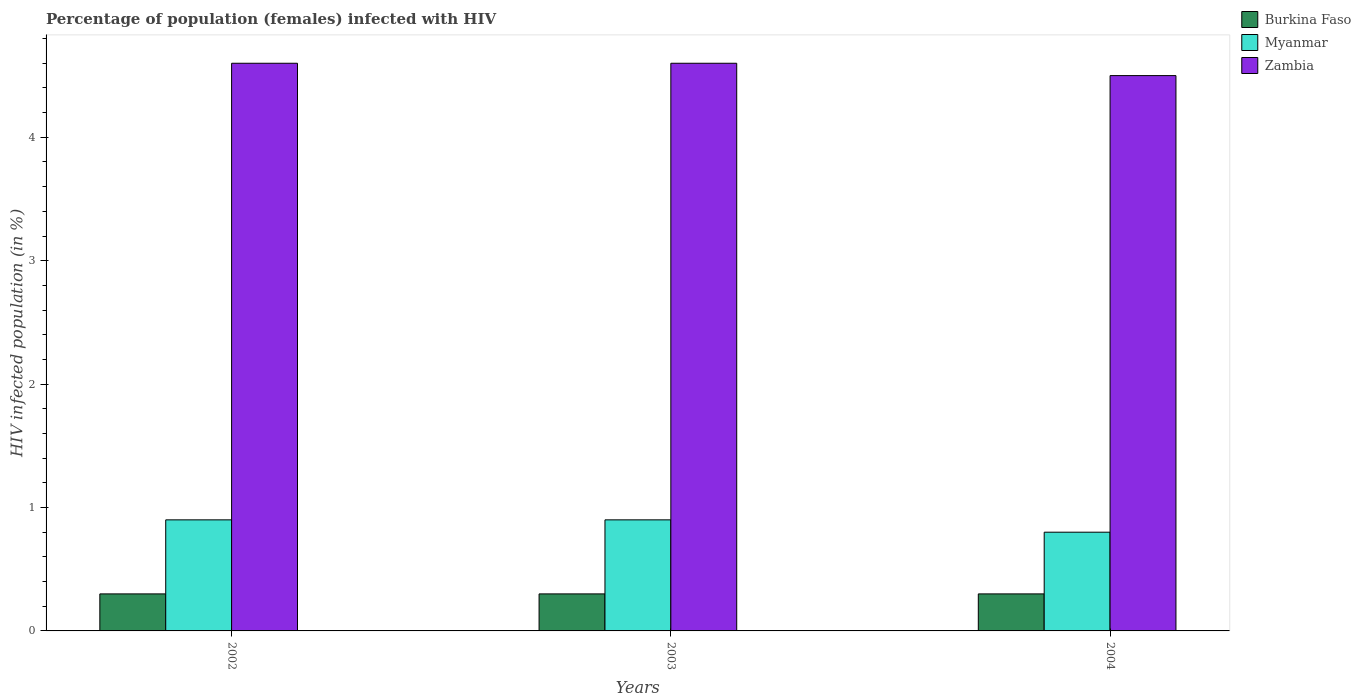How many groups of bars are there?
Offer a very short reply. 3. Are the number of bars per tick equal to the number of legend labels?
Offer a very short reply. Yes. How many bars are there on the 3rd tick from the left?
Ensure brevity in your answer.  3. What is the label of the 1st group of bars from the left?
Your response must be concise. 2002. What is the percentage of HIV infected female population in Zambia in 2003?
Your answer should be compact. 4.6. Across all years, what is the minimum percentage of HIV infected female population in Burkina Faso?
Ensure brevity in your answer.  0.3. In which year was the percentage of HIV infected female population in Burkina Faso maximum?
Provide a short and direct response. 2002. What is the total percentage of HIV infected female population in Zambia in the graph?
Your answer should be very brief. 13.7. What is the difference between the percentage of HIV infected female population in Myanmar in 2003 and that in 2004?
Provide a succinct answer. 0.1. What is the average percentage of HIV infected female population in Myanmar per year?
Give a very brief answer. 0.87. In how many years, is the percentage of HIV infected female population in Myanmar greater than 1.2 %?
Your answer should be very brief. 0. What is the ratio of the percentage of HIV infected female population in Burkina Faso in 2002 to that in 2004?
Give a very brief answer. 1. What does the 3rd bar from the left in 2003 represents?
Offer a terse response. Zambia. What does the 3rd bar from the right in 2002 represents?
Provide a short and direct response. Burkina Faso. Is it the case that in every year, the sum of the percentage of HIV infected female population in Zambia and percentage of HIV infected female population in Burkina Faso is greater than the percentage of HIV infected female population in Myanmar?
Offer a very short reply. Yes. How many bars are there?
Ensure brevity in your answer.  9. Are all the bars in the graph horizontal?
Give a very brief answer. No. How many years are there in the graph?
Your answer should be very brief. 3. Are the values on the major ticks of Y-axis written in scientific E-notation?
Provide a succinct answer. No. Does the graph contain any zero values?
Offer a terse response. No. Does the graph contain grids?
Provide a succinct answer. No. Where does the legend appear in the graph?
Make the answer very short. Top right. How many legend labels are there?
Provide a short and direct response. 3. What is the title of the graph?
Ensure brevity in your answer.  Percentage of population (females) infected with HIV. What is the label or title of the Y-axis?
Provide a succinct answer. HIV infected population (in %). What is the HIV infected population (in %) of Burkina Faso in 2002?
Provide a succinct answer. 0.3. What is the HIV infected population (in %) in Myanmar in 2002?
Offer a terse response. 0.9. What is the HIV infected population (in %) in Zambia in 2002?
Offer a very short reply. 4.6. What is the HIV infected population (in %) of Zambia in 2003?
Ensure brevity in your answer.  4.6. What is the HIV infected population (in %) of Burkina Faso in 2004?
Make the answer very short. 0.3. What is the HIV infected population (in %) in Zambia in 2004?
Make the answer very short. 4.5. Across all years, what is the maximum HIV infected population (in %) in Burkina Faso?
Your response must be concise. 0.3. Across all years, what is the maximum HIV infected population (in %) in Myanmar?
Your response must be concise. 0.9. Across all years, what is the minimum HIV infected population (in %) in Burkina Faso?
Provide a short and direct response. 0.3. Across all years, what is the minimum HIV infected population (in %) in Myanmar?
Offer a very short reply. 0.8. Across all years, what is the minimum HIV infected population (in %) in Zambia?
Provide a short and direct response. 4.5. What is the total HIV infected population (in %) of Myanmar in the graph?
Give a very brief answer. 2.6. What is the difference between the HIV infected population (in %) of Myanmar in 2002 and that in 2003?
Your answer should be very brief. 0. What is the difference between the HIV infected population (in %) in Burkina Faso in 2002 and that in 2004?
Keep it short and to the point. 0. What is the difference between the HIV infected population (in %) in Myanmar in 2003 and that in 2004?
Ensure brevity in your answer.  0.1. What is the difference between the HIV infected population (in %) of Zambia in 2003 and that in 2004?
Keep it short and to the point. 0.1. What is the difference between the HIV infected population (in %) in Burkina Faso in 2002 and the HIV infected population (in %) in Zambia in 2003?
Your response must be concise. -4.3. What is the difference between the HIV infected population (in %) in Burkina Faso in 2002 and the HIV infected population (in %) in Myanmar in 2004?
Your answer should be compact. -0.5. What is the difference between the HIV infected population (in %) in Myanmar in 2002 and the HIV infected population (in %) in Zambia in 2004?
Provide a short and direct response. -3.6. What is the difference between the HIV infected population (in %) of Burkina Faso in 2003 and the HIV infected population (in %) of Myanmar in 2004?
Your answer should be very brief. -0.5. What is the difference between the HIV infected population (in %) in Myanmar in 2003 and the HIV infected population (in %) in Zambia in 2004?
Keep it short and to the point. -3.6. What is the average HIV infected population (in %) in Myanmar per year?
Make the answer very short. 0.87. What is the average HIV infected population (in %) of Zambia per year?
Ensure brevity in your answer.  4.57. In the year 2002, what is the difference between the HIV infected population (in %) of Burkina Faso and HIV infected population (in %) of Zambia?
Offer a very short reply. -4.3. In the year 2002, what is the difference between the HIV infected population (in %) in Myanmar and HIV infected population (in %) in Zambia?
Keep it short and to the point. -3.7. In the year 2003, what is the difference between the HIV infected population (in %) in Burkina Faso and HIV infected population (in %) in Myanmar?
Keep it short and to the point. -0.6. In the year 2003, what is the difference between the HIV infected population (in %) of Burkina Faso and HIV infected population (in %) of Zambia?
Keep it short and to the point. -4.3. In the year 2003, what is the difference between the HIV infected population (in %) in Myanmar and HIV infected population (in %) in Zambia?
Ensure brevity in your answer.  -3.7. In the year 2004, what is the difference between the HIV infected population (in %) of Burkina Faso and HIV infected population (in %) of Myanmar?
Offer a terse response. -0.5. In the year 2004, what is the difference between the HIV infected population (in %) of Burkina Faso and HIV infected population (in %) of Zambia?
Keep it short and to the point. -4.2. In the year 2004, what is the difference between the HIV infected population (in %) of Myanmar and HIV infected population (in %) of Zambia?
Provide a short and direct response. -3.7. What is the ratio of the HIV infected population (in %) in Myanmar in 2002 to that in 2003?
Your answer should be very brief. 1. What is the ratio of the HIV infected population (in %) in Zambia in 2002 to that in 2004?
Provide a short and direct response. 1.02. What is the ratio of the HIV infected population (in %) of Zambia in 2003 to that in 2004?
Your answer should be very brief. 1.02. What is the difference between the highest and the second highest HIV infected population (in %) in Burkina Faso?
Your answer should be compact. 0. What is the difference between the highest and the second highest HIV infected population (in %) of Zambia?
Offer a very short reply. 0. What is the difference between the highest and the lowest HIV infected population (in %) in Zambia?
Give a very brief answer. 0.1. 